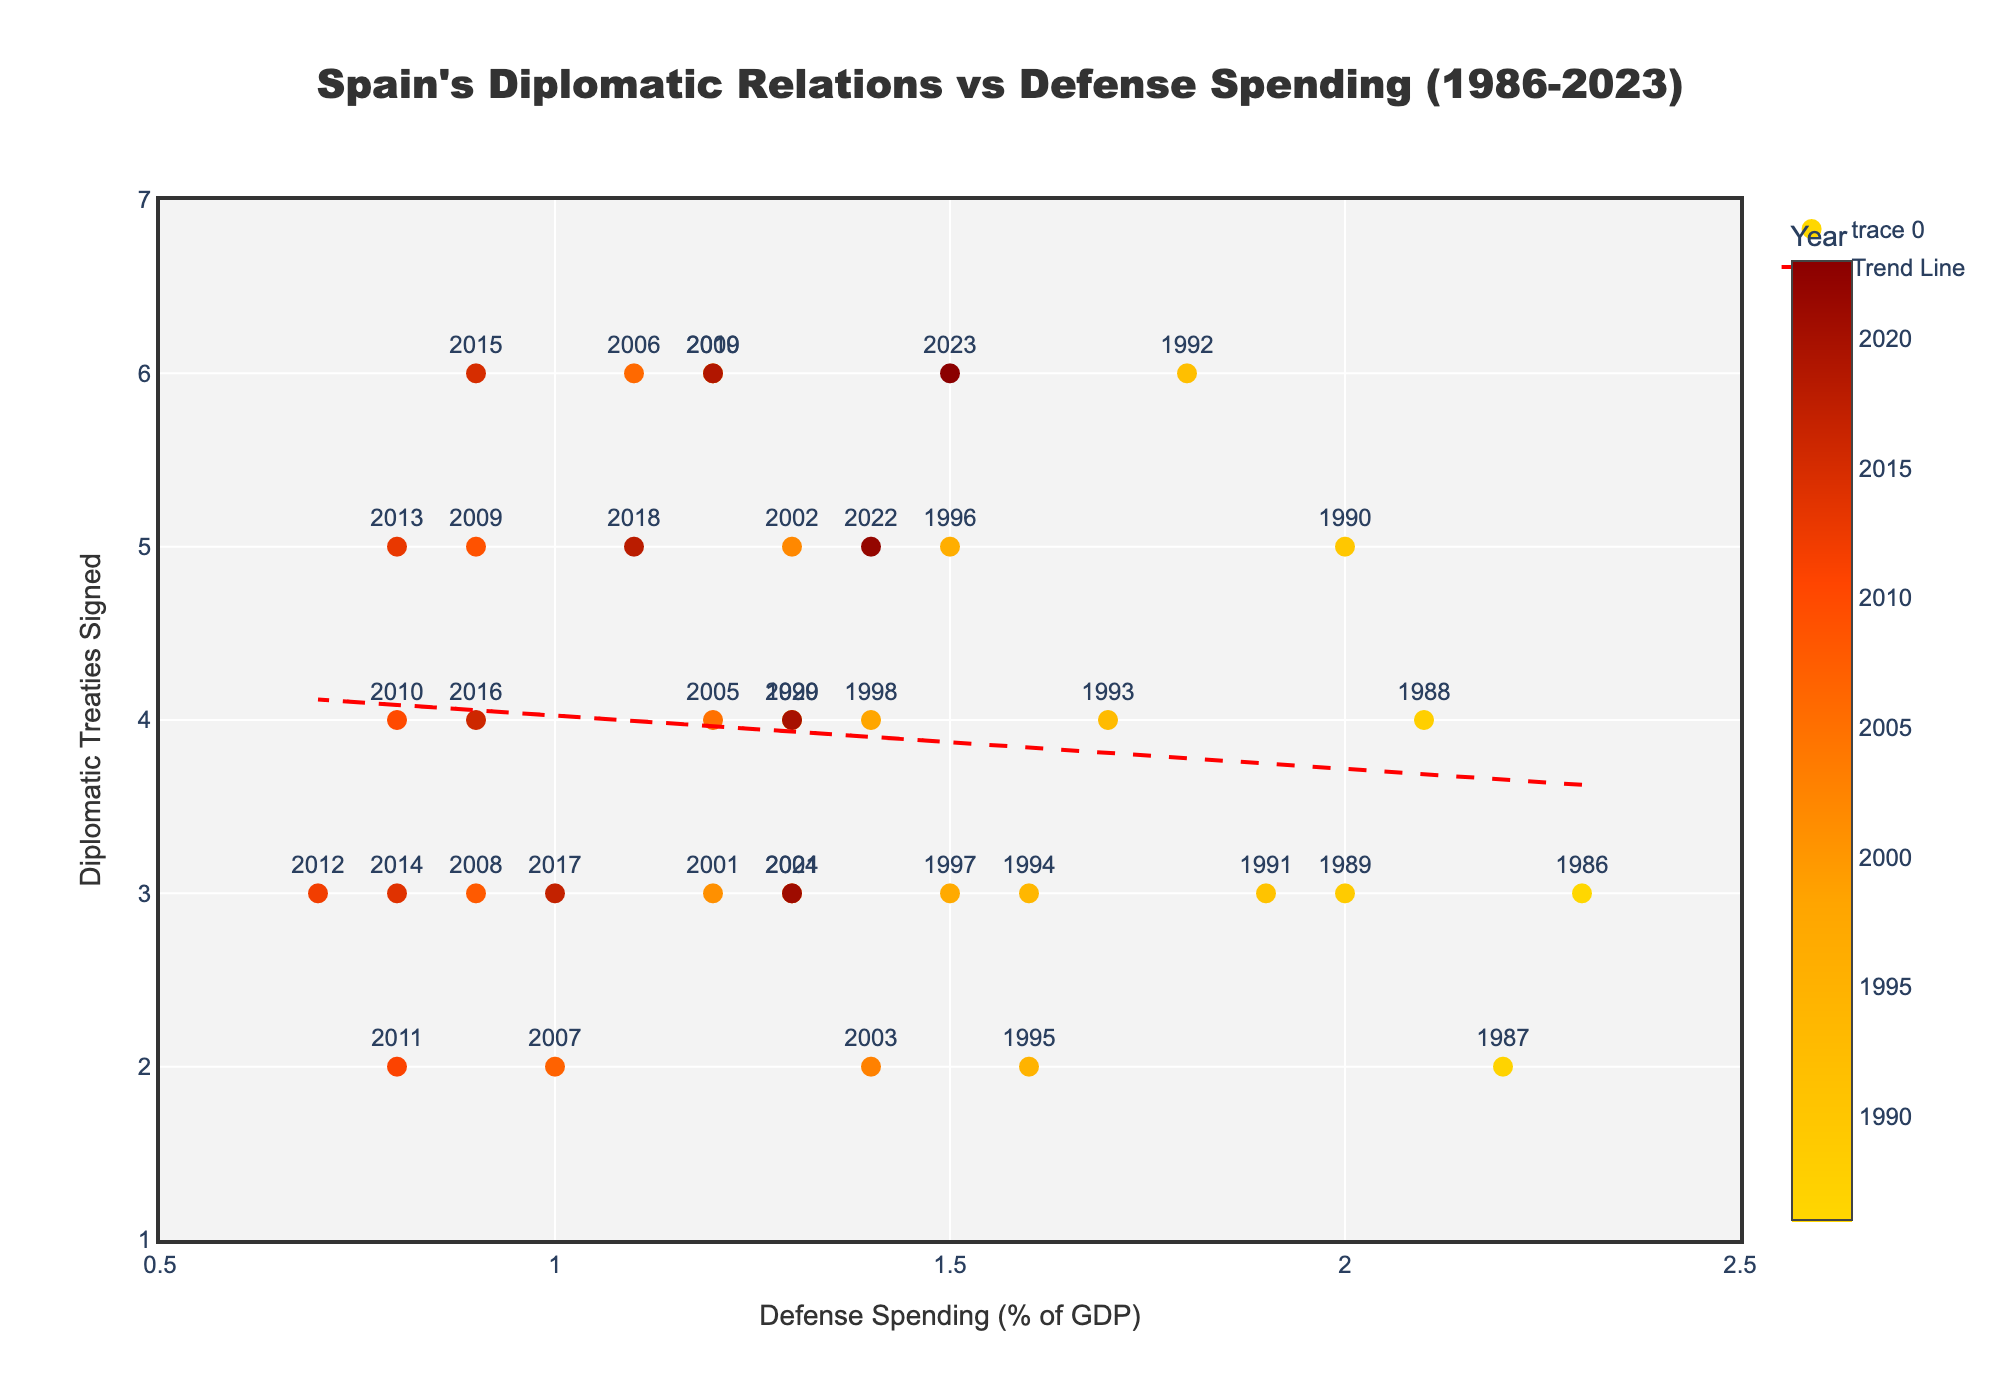What is the title of the figure? The title of the figure is located at the top center and is generally the most prominent text on the plot. By looking at the figure, you will see that the title is "Spain's Diplomatic Relations vs Defense Spending (1986-2023)"
Answer: Spain's Diplomatic Relations vs Defense Spending (1986-2023) How many data points are present in the scatter plot? Each point in the scatter plot represents a year between 1986 and 2023, inclusive. Counting these points gives you the total number of data points, which corresponds to the year range.
Answer: 38 What are the ranges of the x-axis (Defense Spending) and y-axis (Diplomatic Treaties)? The x-axis range can be deduced by looking at the minimum and maximum values of defense spending percentages, while the y-axis range is determined by the minimum and maximum number of diplomatic treaties signed. Both ranges are also defined in the axis settings. For the x-axis, it ranges from 0.5 to 2.5 and for the y-axis, it ranges from 1 to 7.
Answer: x-axis: 0.5 - 2.5, y-axis: 1 - 7 In which year did Spain sign the highest number of diplomatic treaties, and what was the defense spending percentage that year? Look for the data point with the highest y-axis value (diplomatic treaties signed). The corresponding year and defense spending percentage can be found by hovering over the data point or checking the figure. The year with the highest diplomatic treaties signed is 1992, and the defense spending was 1.8 percent.
Answer: 1992, 1.8% Is there a general trend between defense spending and the number of diplomatic treaties signed? A trend can be identified by examining the slope of the trend line. A negative slope suggests that as defense spending increases, the number of diplomatic treaties signed generally decreases. By looking at the trend line in the scatter plot, you can see that there is a slight downward slope.
Answer: Negative trend In what year did defense spending as a percentage of GDP hit its lowest value, and how many diplomatic treaties were signed that year? Find the data point with the lowest x-coordinate (defense spending percentage). Hover over it to identify the year and the number of diplomatic treaties signed. In this case, defense spending hit its lowest at 0.7% in 2012, with 3 treaties signed.
Answer: 2012, 3 Which year had both the highest defense spending percentage and a high number of diplomatic treaties signed? Search for the highest x-coordinate (defense spending percentage) and check its corresponding y-coordinate (diplomatic treaties signed). In the plot, 1986 had the highest defense spending percentage of 2.3%, with 3 treaties signed.
Answer: 1986 What is the average number of diplomatic treaties signed from 2000 to 2020? Select the points within the year range from 2000 to 2020. Sum their y-coordinates (diplomatic treaties) and divide by the number of points within this range. The values are: 6, 3, 5, 2, 3, 4, 6, 2, 3, 5, 4, 2, 3, 5, 3, 6, 4, 3, 5, 4, and 3, summing up to 78. There are 21 points. The average is 78/21.
Answer: 3.71 How did the number of diplomatic treaties change from the year with highest defense spending to the year with lowest defense spending? Identify the years with the highest and lowest defense spending by looking at the x-axis. Compare the y-values (number of treaties) for these years: In 1986 (highest, 2.3%) 3 treaties, and 2012 (lowest, 0.7%) 3 treaties. The number remained the same.
Answer: No change How does the defense spending percentage in 2003 compare to that in 2023? Locate the data points for the years 2003 and 2023 on the scatter plot, and compare their x-coordinates. In 2003, the defense spending was 1.4%, and in 2023, it was 1.5%. By comparing, it can be seen that the defense spending in 2023 is slightly higher than in 2003.
Answer: 2023 is higher by 0.1% 